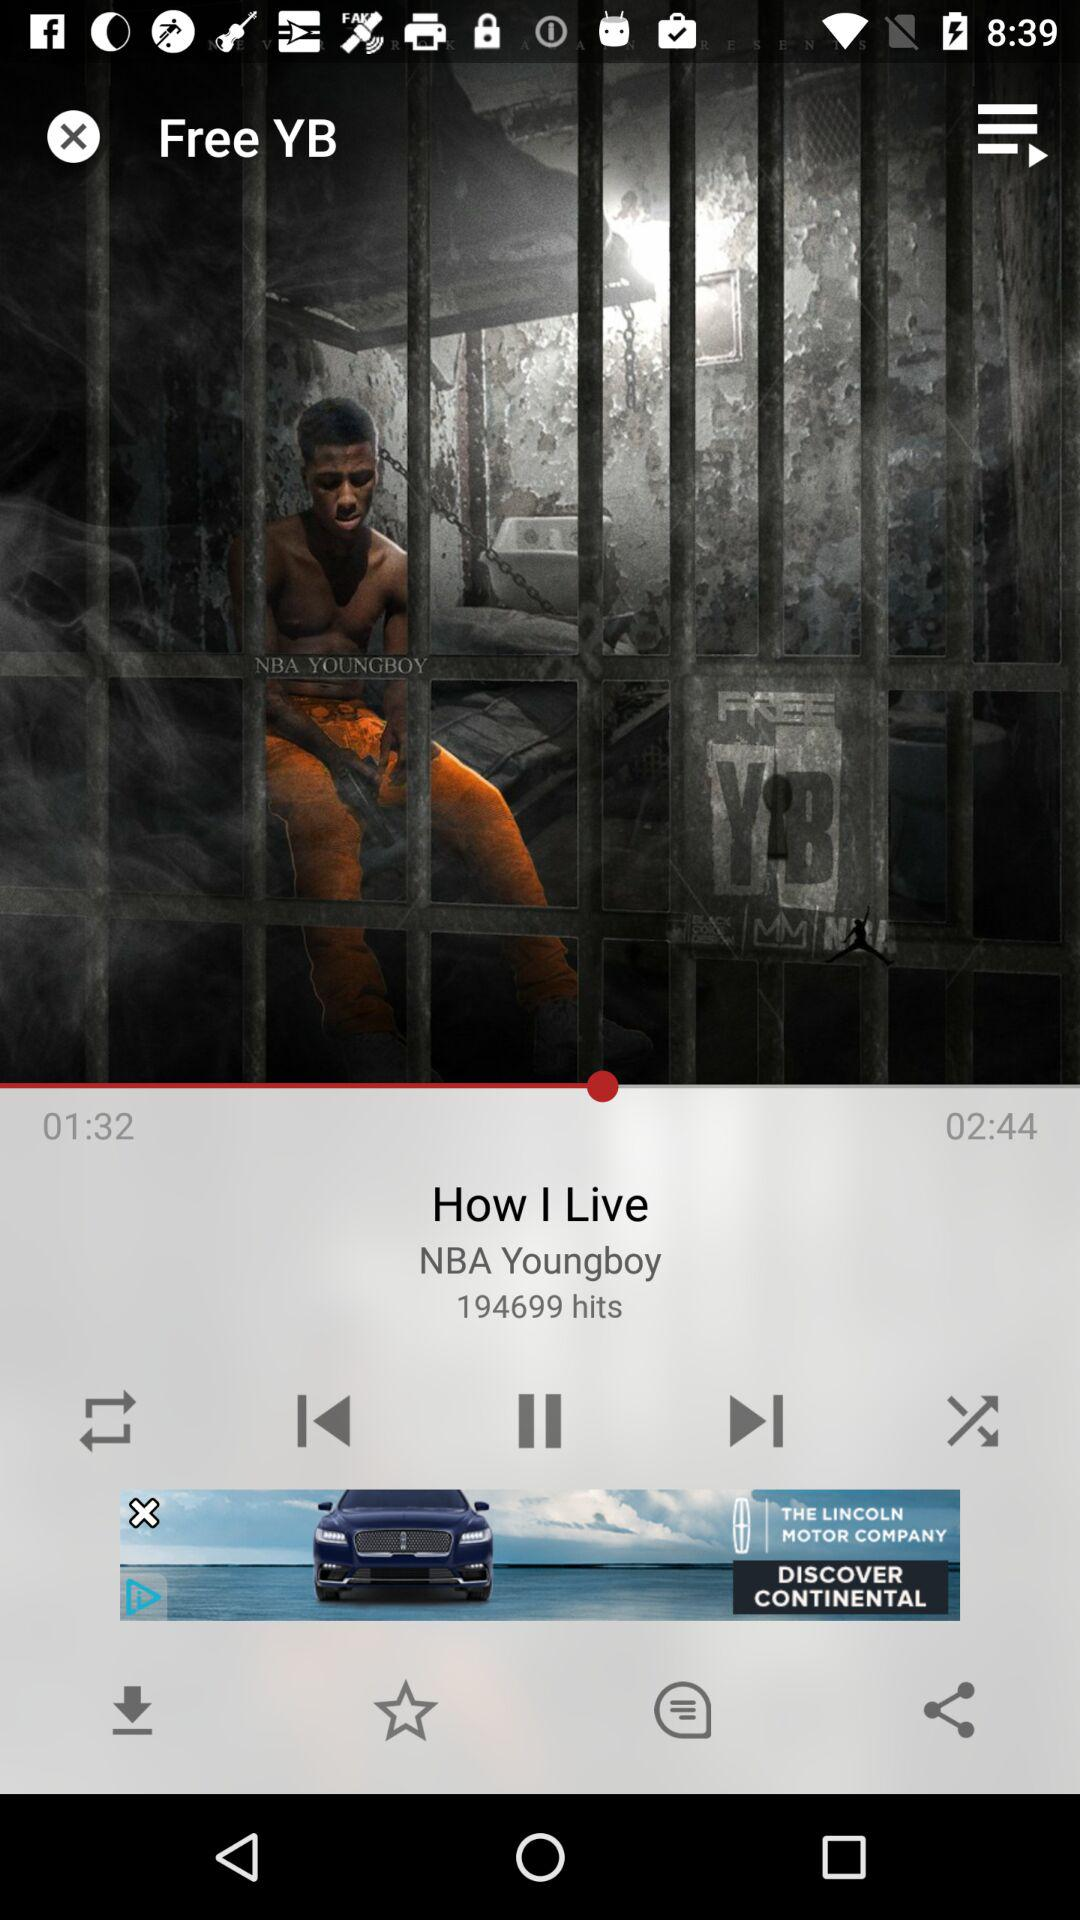What is the duration of the song? The duration of the song is 2 minutes 44 seconds. 